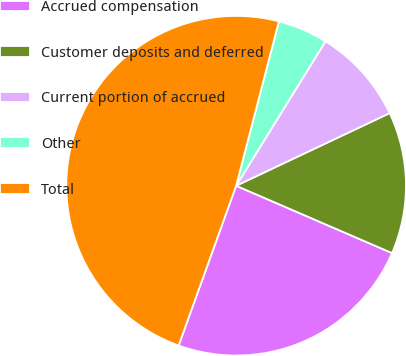Convert chart. <chart><loc_0><loc_0><loc_500><loc_500><pie_chart><fcel>Accrued compensation<fcel>Customer deposits and deferred<fcel>Current portion of accrued<fcel>Other<fcel>Total<nl><fcel>24.01%<fcel>13.52%<fcel>9.15%<fcel>4.77%<fcel>48.55%<nl></chart> 